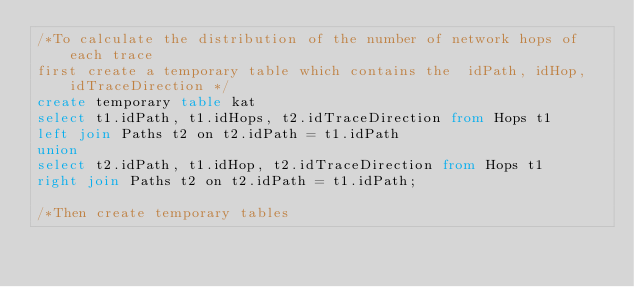Convert code to text. <code><loc_0><loc_0><loc_500><loc_500><_SQL_>/*To calculate the distribution of the number of network hops of each trace
first create a temporary table which contains the  idPath, idHop, idTraceDirection */
create temporary table kat 
select t1.idPath, t1.idHops, t2.idTraceDirection from Hops t1
left join Paths t2 on t2.idPath = t1.idPath
union
select t2.idPath, t1.idHop, t2.idTraceDirection from Hops t1
right join Paths t2 on t2.idPath = t1.idPath;

/*Then create temporary tables</code> 